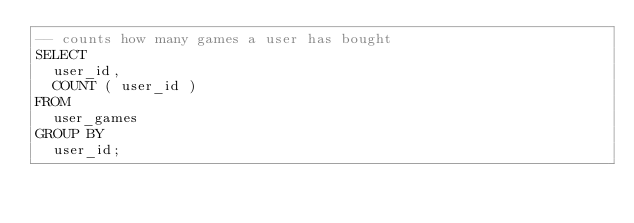Convert code to text. <code><loc_0><loc_0><loc_500><loc_500><_SQL_>-- counts how many games a user has bought
SELECT
	user_id,
	COUNT ( user_id ) 
FROM
	user_games 
GROUP BY
	user_id;</code> 